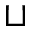Convert formula to latex. <formula><loc_0><loc_0><loc_500><loc_500>\sqcup</formula> 